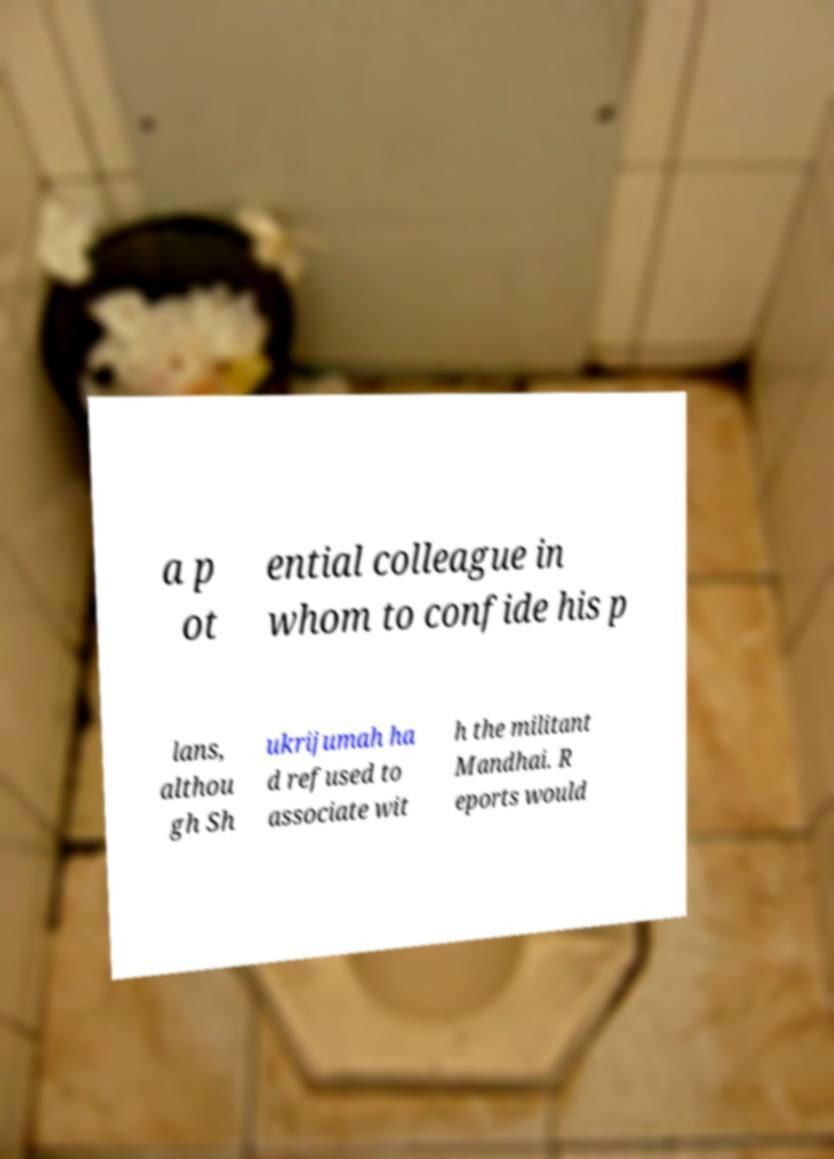There's text embedded in this image that I need extracted. Can you transcribe it verbatim? a p ot ential colleague in whom to confide his p lans, althou gh Sh ukrijumah ha d refused to associate wit h the militant Mandhai. R eports would 